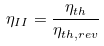<formula> <loc_0><loc_0><loc_500><loc_500>\eta _ { I I } = \frac { \eta _ { t h } } { \eta _ { t h , r e v } }</formula> 